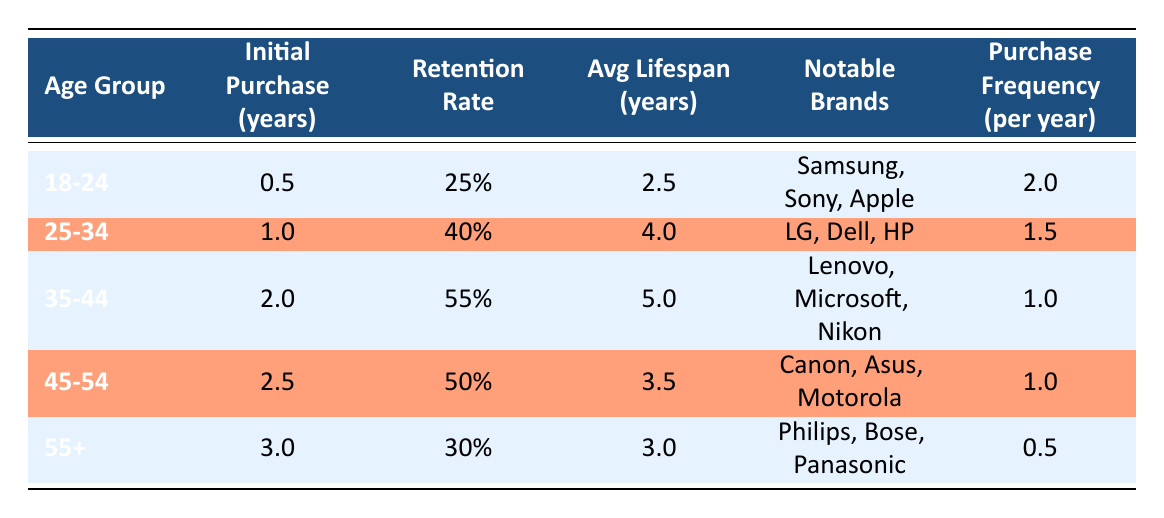What is the average customer lifespan for the age group 35-44? The average lifespan for the age group 35-44 is listed directly in the table under "Avg Lifespan (years)", which states it is 5.0 years.
Answer: 5.0 What is the retention rate for customers aged 45-54? Looking at the "Retention Rate" column, the age group 45-54 has a retention rate of 50%.
Answer: 50% Which age group has the highest purchase frequency per year? Comparing the "Purchase Frequency (per year)" values across age groups, the highest is 2.0 for the age group 18-24.
Answer: 18-24 Are any brands notable for customers aged 55 and older? The "Notable Brands" for the group aged 55+ includes Philips, Bose, and Panasonic, confirming that there are notable brands for this age group.
Answer: Yes How does the average lifespan change from the age group 25-34 to 35-44? The average lifespan for 25-34 is 4.0 years and for 35-44 it is 5.0 years. The change is an increase of 1.0 year from one group to the other.
Answer: Increase by 1.0 year What is the average retention rate for all age groups combined? To find the average retention rate, we add the retention rates: 25% + 40% + 55% + 50% + 30% = 200% and divide by 5 (the number of age groups), resulting in an average retention rate of 40%.
Answer: 40% Which age group has the lowest retention rate, and what is that rate? By examining the "Retention Rate" column, the lowest rate is 25% for the age group 18-24.
Answer: 18-24, 25% What is the initial purchase year average across all age groups? Adding initial purchase years: 0.5 + 1 + 2 + 2.5 + 3 = 9 years. Then we divide by 5 age groups to find the average: 9/5 = 1.8 years.
Answer: 1.8 years Which age group has a notable brand associated with both electronics and photography? The age group 35-44 lists Nikon as a notable brand, which is associated with photography, as well as electronics.
Answer: 35-44 